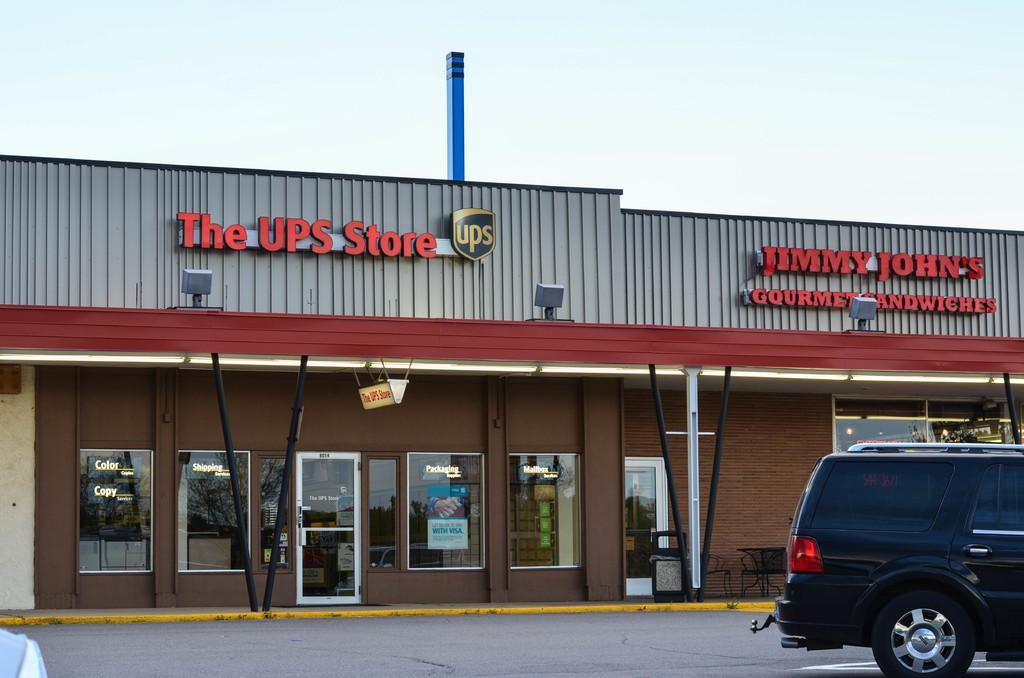What can be seen at the top of the image? The sky is visible at the top of the image. What type of establishments are present in the image? There are stores in the image. Where is the vehicle located in the image? The vehicle is on the right side of the image. How many frogs are sitting on the tongue of the vehicle in the image? There are no frogs or tongues present on the vehicle in the image. What type of hook is attached to the vehicle in the image? There is no hook present on the vehicle in the image. 